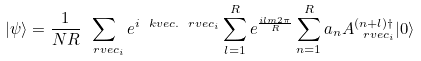<formula> <loc_0><loc_0><loc_500><loc_500>| \psi \rangle = \frac { 1 } { N R } \sum _ { \ r v e c _ { i } } e ^ { i \ k v e c . \ r v e c _ { i } } \sum _ { l = 1 } ^ { R } e ^ { \frac { i l m 2 \pi } { R } } \sum _ { n = 1 } ^ { R } a _ { n } A ^ { ( n + l ) \dagger } _ { \ r v e c _ { i } } | 0 \rangle</formula> 